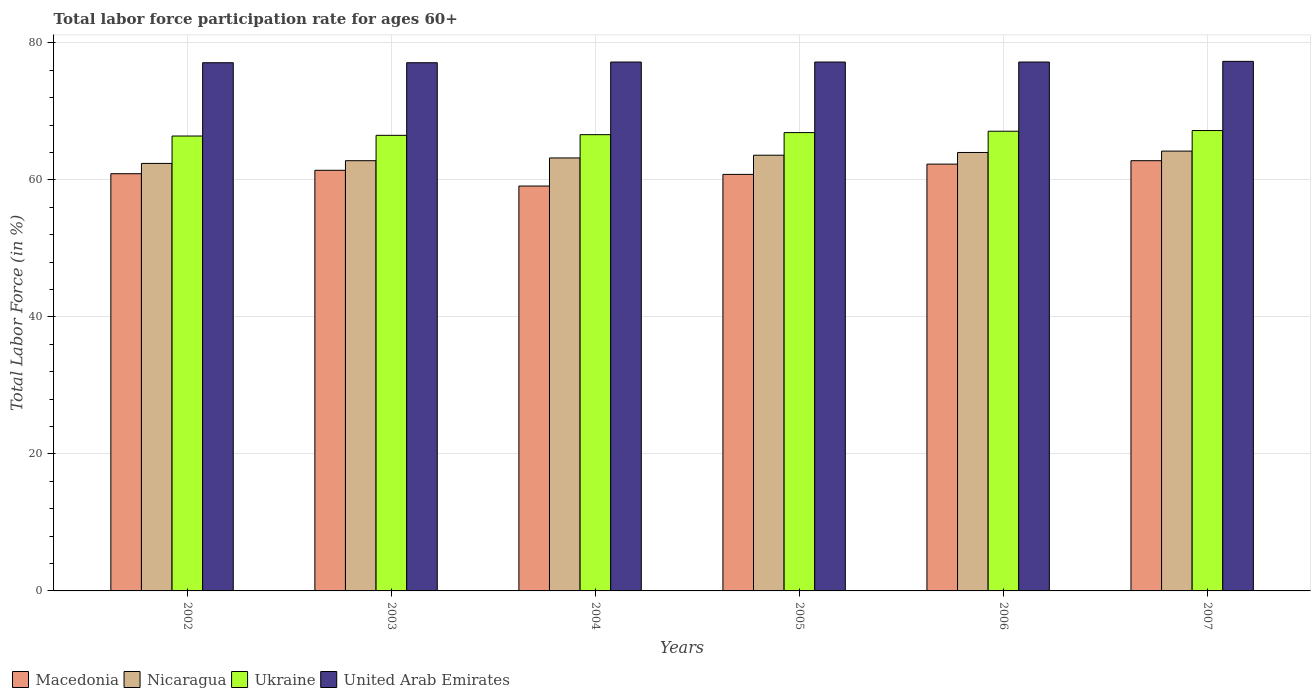How many different coloured bars are there?
Your answer should be very brief. 4. How many groups of bars are there?
Make the answer very short. 6. Are the number of bars per tick equal to the number of legend labels?
Your answer should be compact. Yes. Are the number of bars on each tick of the X-axis equal?
Your response must be concise. Yes. How many bars are there on the 1st tick from the right?
Give a very brief answer. 4. What is the labor force participation rate in United Arab Emirates in 2006?
Your answer should be very brief. 77.2. Across all years, what is the maximum labor force participation rate in Ukraine?
Your response must be concise. 67.2. Across all years, what is the minimum labor force participation rate in United Arab Emirates?
Give a very brief answer. 77.1. In which year was the labor force participation rate in Ukraine maximum?
Offer a very short reply. 2007. What is the total labor force participation rate in United Arab Emirates in the graph?
Your response must be concise. 463.1. What is the difference between the labor force participation rate in Ukraine in 2003 and that in 2005?
Make the answer very short. -0.4. What is the difference between the labor force participation rate in United Arab Emirates in 2007 and the labor force participation rate in Nicaragua in 2005?
Your response must be concise. 13.7. What is the average labor force participation rate in United Arab Emirates per year?
Provide a short and direct response. 77.18. In the year 2007, what is the difference between the labor force participation rate in Ukraine and labor force participation rate in Macedonia?
Your answer should be very brief. 4.4. What is the ratio of the labor force participation rate in Ukraine in 2002 to that in 2006?
Make the answer very short. 0.99. Is the difference between the labor force participation rate in Ukraine in 2006 and 2007 greater than the difference between the labor force participation rate in Macedonia in 2006 and 2007?
Your answer should be compact. Yes. What is the difference between the highest and the second highest labor force participation rate in Ukraine?
Your answer should be compact. 0.1. What is the difference between the highest and the lowest labor force participation rate in Nicaragua?
Offer a terse response. 1.8. Is it the case that in every year, the sum of the labor force participation rate in Nicaragua and labor force participation rate in United Arab Emirates is greater than the sum of labor force participation rate in Macedonia and labor force participation rate in Ukraine?
Offer a very short reply. Yes. What does the 4th bar from the left in 2002 represents?
Keep it short and to the point. United Arab Emirates. What does the 2nd bar from the right in 2006 represents?
Make the answer very short. Ukraine. How many bars are there?
Offer a very short reply. 24. Are all the bars in the graph horizontal?
Your answer should be compact. No. How many years are there in the graph?
Give a very brief answer. 6. Does the graph contain grids?
Your response must be concise. Yes. How are the legend labels stacked?
Your answer should be very brief. Horizontal. What is the title of the graph?
Provide a succinct answer. Total labor force participation rate for ages 60+. Does "North America" appear as one of the legend labels in the graph?
Provide a short and direct response. No. What is the label or title of the Y-axis?
Give a very brief answer. Total Labor Force (in %). What is the Total Labor Force (in %) of Macedonia in 2002?
Your response must be concise. 60.9. What is the Total Labor Force (in %) in Nicaragua in 2002?
Provide a short and direct response. 62.4. What is the Total Labor Force (in %) in Ukraine in 2002?
Give a very brief answer. 66.4. What is the Total Labor Force (in %) of United Arab Emirates in 2002?
Offer a terse response. 77.1. What is the Total Labor Force (in %) of Macedonia in 2003?
Give a very brief answer. 61.4. What is the Total Labor Force (in %) in Nicaragua in 2003?
Offer a very short reply. 62.8. What is the Total Labor Force (in %) in Ukraine in 2003?
Offer a very short reply. 66.5. What is the Total Labor Force (in %) in United Arab Emirates in 2003?
Your answer should be compact. 77.1. What is the Total Labor Force (in %) of Macedonia in 2004?
Give a very brief answer. 59.1. What is the Total Labor Force (in %) of Nicaragua in 2004?
Provide a succinct answer. 63.2. What is the Total Labor Force (in %) of Ukraine in 2004?
Provide a short and direct response. 66.6. What is the Total Labor Force (in %) in United Arab Emirates in 2004?
Provide a short and direct response. 77.2. What is the Total Labor Force (in %) in Macedonia in 2005?
Make the answer very short. 60.8. What is the Total Labor Force (in %) in Nicaragua in 2005?
Ensure brevity in your answer.  63.6. What is the Total Labor Force (in %) of Ukraine in 2005?
Make the answer very short. 66.9. What is the Total Labor Force (in %) in United Arab Emirates in 2005?
Ensure brevity in your answer.  77.2. What is the Total Labor Force (in %) in Macedonia in 2006?
Make the answer very short. 62.3. What is the Total Labor Force (in %) in Ukraine in 2006?
Your answer should be very brief. 67.1. What is the Total Labor Force (in %) in United Arab Emirates in 2006?
Offer a terse response. 77.2. What is the Total Labor Force (in %) of Macedonia in 2007?
Your answer should be very brief. 62.8. What is the Total Labor Force (in %) in Nicaragua in 2007?
Keep it short and to the point. 64.2. What is the Total Labor Force (in %) in Ukraine in 2007?
Provide a succinct answer. 67.2. What is the Total Labor Force (in %) of United Arab Emirates in 2007?
Make the answer very short. 77.3. Across all years, what is the maximum Total Labor Force (in %) of Macedonia?
Your answer should be compact. 62.8. Across all years, what is the maximum Total Labor Force (in %) of Nicaragua?
Provide a short and direct response. 64.2. Across all years, what is the maximum Total Labor Force (in %) in Ukraine?
Give a very brief answer. 67.2. Across all years, what is the maximum Total Labor Force (in %) in United Arab Emirates?
Your answer should be very brief. 77.3. Across all years, what is the minimum Total Labor Force (in %) in Macedonia?
Give a very brief answer. 59.1. Across all years, what is the minimum Total Labor Force (in %) in Nicaragua?
Offer a very short reply. 62.4. Across all years, what is the minimum Total Labor Force (in %) of Ukraine?
Your answer should be compact. 66.4. Across all years, what is the minimum Total Labor Force (in %) in United Arab Emirates?
Offer a very short reply. 77.1. What is the total Total Labor Force (in %) in Macedonia in the graph?
Offer a terse response. 367.3. What is the total Total Labor Force (in %) in Nicaragua in the graph?
Make the answer very short. 380.2. What is the total Total Labor Force (in %) of Ukraine in the graph?
Offer a very short reply. 400.7. What is the total Total Labor Force (in %) of United Arab Emirates in the graph?
Your answer should be compact. 463.1. What is the difference between the Total Labor Force (in %) of Macedonia in 2002 and that in 2003?
Provide a short and direct response. -0.5. What is the difference between the Total Labor Force (in %) in Nicaragua in 2002 and that in 2003?
Give a very brief answer. -0.4. What is the difference between the Total Labor Force (in %) of Ukraine in 2002 and that in 2003?
Keep it short and to the point. -0.1. What is the difference between the Total Labor Force (in %) in United Arab Emirates in 2002 and that in 2003?
Ensure brevity in your answer.  0. What is the difference between the Total Labor Force (in %) in Nicaragua in 2002 and that in 2004?
Keep it short and to the point. -0.8. What is the difference between the Total Labor Force (in %) in United Arab Emirates in 2002 and that in 2004?
Keep it short and to the point. -0.1. What is the difference between the Total Labor Force (in %) of Macedonia in 2002 and that in 2005?
Make the answer very short. 0.1. What is the difference between the Total Labor Force (in %) of Macedonia in 2002 and that in 2006?
Your answer should be compact. -1.4. What is the difference between the Total Labor Force (in %) of Nicaragua in 2002 and that in 2006?
Your answer should be very brief. -1.6. What is the difference between the Total Labor Force (in %) of Ukraine in 2002 and that in 2006?
Offer a very short reply. -0.7. What is the difference between the Total Labor Force (in %) in Macedonia in 2002 and that in 2007?
Ensure brevity in your answer.  -1.9. What is the difference between the Total Labor Force (in %) in Nicaragua in 2002 and that in 2007?
Provide a succinct answer. -1.8. What is the difference between the Total Labor Force (in %) of Nicaragua in 2003 and that in 2004?
Your answer should be compact. -0.4. What is the difference between the Total Labor Force (in %) of Nicaragua in 2003 and that in 2005?
Your answer should be very brief. -0.8. What is the difference between the Total Labor Force (in %) of Ukraine in 2003 and that in 2005?
Ensure brevity in your answer.  -0.4. What is the difference between the Total Labor Force (in %) in Macedonia in 2003 and that in 2006?
Give a very brief answer. -0.9. What is the difference between the Total Labor Force (in %) of Ukraine in 2003 and that in 2006?
Keep it short and to the point. -0.6. What is the difference between the Total Labor Force (in %) of Nicaragua in 2003 and that in 2007?
Offer a terse response. -1.4. What is the difference between the Total Labor Force (in %) of Ukraine in 2003 and that in 2007?
Provide a succinct answer. -0.7. What is the difference between the Total Labor Force (in %) in Macedonia in 2004 and that in 2005?
Offer a very short reply. -1.7. What is the difference between the Total Labor Force (in %) in Nicaragua in 2004 and that in 2005?
Make the answer very short. -0.4. What is the difference between the Total Labor Force (in %) in Ukraine in 2004 and that in 2005?
Give a very brief answer. -0.3. What is the difference between the Total Labor Force (in %) in Macedonia in 2004 and that in 2006?
Your answer should be compact. -3.2. What is the difference between the Total Labor Force (in %) in Ukraine in 2004 and that in 2006?
Your answer should be very brief. -0.5. What is the difference between the Total Labor Force (in %) of United Arab Emirates in 2004 and that in 2006?
Give a very brief answer. 0. What is the difference between the Total Labor Force (in %) of Macedonia in 2004 and that in 2007?
Offer a terse response. -3.7. What is the difference between the Total Labor Force (in %) of Nicaragua in 2004 and that in 2007?
Offer a terse response. -1. What is the difference between the Total Labor Force (in %) in Nicaragua in 2005 and that in 2006?
Offer a very short reply. -0.4. What is the difference between the Total Labor Force (in %) in Ukraine in 2005 and that in 2006?
Provide a short and direct response. -0.2. What is the difference between the Total Labor Force (in %) in United Arab Emirates in 2005 and that in 2007?
Make the answer very short. -0.1. What is the difference between the Total Labor Force (in %) of Macedonia in 2006 and that in 2007?
Offer a very short reply. -0.5. What is the difference between the Total Labor Force (in %) in Nicaragua in 2006 and that in 2007?
Your response must be concise. -0.2. What is the difference between the Total Labor Force (in %) of Ukraine in 2006 and that in 2007?
Offer a terse response. -0.1. What is the difference between the Total Labor Force (in %) of United Arab Emirates in 2006 and that in 2007?
Ensure brevity in your answer.  -0.1. What is the difference between the Total Labor Force (in %) of Macedonia in 2002 and the Total Labor Force (in %) of United Arab Emirates in 2003?
Make the answer very short. -16.2. What is the difference between the Total Labor Force (in %) in Nicaragua in 2002 and the Total Labor Force (in %) in Ukraine in 2003?
Offer a very short reply. -4.1. What is the difference between the Total Labor Force (in %) of Nicaragua in 2002 and the Total Labor Force (in %) of United Arab Emirates in 2003?
Provide a succinct answer. -14.7. What is the difference between the Total Labor Force (in %) in Ukraine in 2002 and the Total Labor Force (in %) in United Arab Emirates in 2003?
Make the answer very short. -10.7. What is the difference between the Total Labor Force (in %) of Macedonia in 2002 and the Total Labor Force (in %) of Ukraine in 2004?
Give a very brief answer. -5.7. What is the difference between the Total Labor Force (in %) in Macedonia in 2002 and the Total Labor Force (in %) in United Arab Emirates in 2004?
Make the answer very short. -16.3. What is the difference between the Total Labor Force (in %) of Nicaragua in 2002 and the Total Labor Force (in %) of United Arab Emirates in 2004?
Your answer should be compact. -14.8. What is the difference between the Total Labor Force (in %) of Macedonia in 2002 and the Total Labor Force (in %) of Nicaragua in 2005?
Keep it short and to the point. -2.7. What is the difference between the Total Labor Force (in %) of Macedonia in 2002 and the Total Labor Force (in %) of Ukraine in 2005?
Ensure brevity in your answer.  -6. What is the difference between the Total Labor Force (in %) in Macedonia in 2002 and the Total Labor Force (in %) in United Arab Emirates in 2005?
Give a very brief answer. -16.3. What is the difference between the Total Labor Force (in %) of Nicaragua in 2002 and the Total Labor Force (in %) of United Arab Emirates in 2005?
Keep it short and to the point. -14.8. What is the difference between the Total Labor Force (in %) of Macedonia in 2002 and the Total Labor Force (in %) of United Arab Emirates in 2006?
Provide a succinct answer. -16.3. What is the difference between the Total Labor Force (in %) of Nicaragua in 2002 and the Total Labor Force (in %) of Ukraine in 2006?
Provide a short and direct response. -4.7. What is the difference between the Total Labor Force (in %) in Nicaragua in 2002 and the Total Labor Force (in %) in United Arab Emirates in 2006?
Keep it short and to the point. -14.8. What is the difference between the Total Labor Force (in %) in Ukraine in 2002 and the Total Labor Force (in %) in United Arab Emirates in 2006?
Your answer should be compact. -10.8. What is the difference between the Total Labor Force (in %) of Macedonia in 2002 and the Total Labor Force (in %) of Nicaragua in 2007?
Offer a very short reply. -3.3. What is the difference between the Total Labor Force (in %) in Macedonia in 2002 and the Total Labor Force (in %) in United Arab Emirates in 2007?
Your answer should be very brief. -16.4. What is the difference between the Total Labor Force (in %) in Nicaragua in 2002 and the Total Labor Force (in %) in Ukraine in 2007?
Keep it short and to the point. -4.8. What is the difference between the Total Labor Force (in %) of Nicaragua in 2002 and the Total Labor Force (in %) of United Arab Emirates in 2007?
Offer a terse response. -14.9. What is the difference between the Total Labor Force (in %) of Macedonia in 2003 and the Total Labor Force (in %) of Nicaragua in 2004?
Give a very brief answer. -1.8. What is the difference between the Total Labor Force (in %) of Macedonia in 2003 and the Total Labor Force (in %) of United Arab Emirates in 2004?
Ensure brevity in your answer.  -15.8. What is the difference between the Total Labor Force (in %) of Nicaragua in 2003 and the Total Labor Force (in %) of United Arab Emirates in 2004?
Your answer should be very brief. -14.4. What is the difference between the Total Labor Force (in %) of Ukraine in 2003 and the Total Labor Force (in %) of United Arab Emirates in 2004?
Your response must be concise. -10.7. What is the difference between the Total Labor Force (in %) in Macedonia in 2003 and the Total Labor Force (in %) in Nicaragua in 2005?
Your answer should be very brief. -2.2. What is the difference between the Total Labor Force (in %) of Macedonia in 2003 and the Total Labor Force (in %) of United Arab Emirates in 2005?
Ensure brevity in your answer.  -15.8. What is the difference between the Total Labor Force (in %) of Nicaragua in 2003 and the Total Labor Force (in %) of United Arab Emirates in 2005?
Your response must be concise. -14.4. What is the difference between the Total Labor Force (in %) in Ukraine in 2003 and the Total Labor Force (in %) in United Arab Emirates in 2005?
Offer a very short reply. -10.7. What is the difference between the Total Labor Force (in %) of Macedonia in 2003 and the Total Labor Force (in %) of Ukraine in 2006?
Keep it short and to the point. -5.7. What is the difference between the Total Labor Force (in %) in Macedonia in 2003 and the Total Labor Force (in %) in United Arab Emirates in 2006?
Ensure brevity in your answer.  -15.8. What is the difference between the Total Labor Force (in %) of Nicaragua in 2003 and the Total Labor Force (in %) of Ukraine in 2006?
Provide a short and direct response. -4.3. What is the difference between the Total Labor Force (in %) in Nicaragua in 2003 and the Total Labor Force (in %) in United Arab Emirates in 2006?
Offer a terse response. -14.4. What is the difference between the Total Labor Force (in %) in Macedonia in 2003 and the Total Labor Force (in %) in United Arab Emirates in 2007?
Provide a succinct answer. -15.9. What is the difference between the Total Labor Force (in %) of Nicaragua in 2003 and the Total Labor Force (in %) of Ukraine in 2007?
Your answer should be very brief. -4.4. What is the difference between the Total Labor Force (in %) in Macedonia in 2004 and the Total Labor Force (in %) in Nicaragua in 2005?
Your answer should be compact. -4.5. What is the difference between the Total Labor Force (in %) of Macedonia in 2004 and the Total Labor Force (in %) of United Arab Emirates in 2005?
Offer a terse response. -18.1. What is the difference between the Total Labor Force (in %) in Nicaragua in 2004 and the Total Labor Force (in %) in United Arab Emirates in 2005?
Keep it short and to the point. -14. What is the difference between the Total Labor Force (in %) of Macedonia in 2004 and the Total Labor Force (in %) of Nicaragua in 2006?
Ensure brevity in your answer.  -4.9. What is the difference between the Total Labor Force (in %) in Macedonia in 2004 and the Total Labor Force (in %) in United Arab Emirates in 2006?
Your response must be concise. -18.1. What is the difference between the Total Labor Force (in %) in Nicaragua in 2004 and the Total Labor Force (in %) in United Arab Emirates in 2006?
Provide a succinct answer. -14. What is the difference between the Total Labor Force (in %) in Ukraine in 2004 and the Total Labor Force (in %) in United Arab Emirates in 2006?
Provide a succinct answer. -10.6. What is the difference between the Total Labor Force (in %) of Macedonia in 2004 and the Total Labor Force (in %) of Nicaragua in 2007?
Keep it short and to the point. -5.1. What is the difference between the Total Labor Force (in %) of Macedonia in 2004 and the Total Labor Force (in %) of United Arab Emirates in 2007?
Keep it short and to the point. -18.2. What is the difference between the Total Labor Force (in %) of Nicaragua in 2004 and the Total Labor Force (in %) of United Arab Emirates in 2007?
Ensure brevity in your answer.  -14.1. What is the difference between the Total Labor Force (in %) of Macedonia in 2005 and the Total Labor Force (in %) of Nicaragua in 2006?
Provide a short and direct response. -3.2. What is the difference between the Total Labor Force (in %) in Macedonia in 2005 and the Total Labor Force (in %) in United Arab Emirates in 2006?
Your answer should be compact. -16.4. What is the difference between the Total Labor Force (in %) of Ukraine in 2005 and the Total Labor Force (in %) of United Arab Emirates in 2006?
Offer a very short reply. -10.3. What is the difference between the Total Labor Force (in %) of Macedonia in 2005 and the Total Labor Force (in %) of United Arab Emirates in 2007?
Provide a short and direct response. -16.5. What is the difference between the Total Labor Force (in %) in Nicaragua in 2005 and the Total Labor Force (in %) in Ukraine in 2007?
Keep it short and to the point. -3.6. What is the difference between the Total Labor Force (in %) of Nicaragua in 2005 and the Total Labor Force (in %) of United Arab Emirates in 2007?
Offer a terse response. -13.7. What is the difference between the Total Labor Force (in %) in Macedonia in 2006 and the Total Labor Force (in %) in Nicaragua in 2007?
Your answer should be very brief. -1.9. What is the difference between the Total Labor Force (in %) in Nicaragua in 2006 and the Total Labor Force (in %) in United Arab Emirates in 2007?
Provide a short and direct response. -13.3. What is the average Total Labor Force (in %) of Macedonia per year?
Keep it short and to the point. 61.22. What is the average Total Labor Force (in %) of Nicaragua per year?
Offer a terse response. 63.37. What is the average Total Labor Force (in %) of Ukraine per year?
Keep it short and to the point. 66.78. What is the average Total Labor Force (in %) of United Arab Emirates per year?
Provide a succinct answer. 77.18. In the year 2002, what is the difference between the Total Labor Force (in %) of Macedonia and Total Labor Force (in %) of Nicaragua?
Provide a short and direct response. -1.5. In the year 2002, what is the difference between the Total Labor Force (in %) in Macedonia and Total Labor Force (in %) in United Arab Emirates?
Offer a very short reply. -16.2. In the year 2002, what is the difference between the Total Labor Force (in %) of Nicaragua and Total Labor Force (in %) of Ukraine?
Offer a very short reply. -4. In the year 2002, what is the difference between the Total Labor Force (in %) of Nicaragua and Total Labor Force (in %) of United Arab Emirates?
Your answer should be compact. -14.7. In the year 2003, what is the difference between the Total Labor Force (in %) in Macedonia and Total Labor Force (in %) in United Arab Emirates?
Keep it short and to the point. -15.7. In the year 2003, what is the difference between the Total Labor Force (in %) in Nicaragua and Total Labor Force (in %) in Ukraine?
Give a very brief answer. -3.7. In the year 2003, what is the difference between the Total Labor Force (in %) of Nicaragua and Total Labor Force (in %) of United Arab Emirates?
Provide a short and direct response. -14.3. In the year 2004, what is the difference between the Total Labor Force (in %) in Macedonia and Total Labor Force (in %) in Nicaragua?
Your answer should be compact. -4.1. In the year 2004, what is the difference between the Total Labor Force (in %) in Macedonia and Total Labor Force (in %) in United Arab Emirates?
Your answer should be compact. -18.1. In the year 2004, what is the difference between the Total Labor Force (in %) of Nicaragua and Total Labor Force (in %) of Ukraine?
Provide a short and direct response. -3.4. In the year 2004, what is the difference between the Total Labor Force (in %) of Ukraine and Total Labor Force (in %) of United Arab Emirates?
Make the answer very short. -10.6. In the year 2005, what is the difference between the Total Labor Force (in %) in Macedonia and Total Labor Force (in %) in Nicaragua?
Your answer should be compact. -2.8. In the year 2005, what is the difference between the Total Labor Force (in %) of Macedonia and Total Labor Force (in %) of United Arab Emirates?
Provide a succinct answer. -16.4. In the year 2005, what is the difference between the Total Labor Force (in %) in Ukraine and Total Labor Force (in %) in United Arab Emirates?
Offer a terse response. -10.3. In the year 2006, what is the difference between the Total Labor Force (in %) of Macedonia and Total Labor Force (in %) of Nicaragua?
Ensure brevity in your answer.  -1.7. In the year 2006, what is the difference between the Total Labor Force (in %) of Macedonia and Total Labor Force (in %) of Ukraine?
Offer a terse response. -4.8. In the year 2006, what is the difference between the Total Labor Force (in %) in Macedonia and Total Labor Force (in %) in United Arab Emirates?
Offer a terse response. -14.9. In the year 2006, what is the difference between the Total Labor Force (in %) of Nicaragua and Total Labor Force (in %) of United Arab Emirates?
Make the answer very short. -13.2. In the year 2007, what is the difference between the Total Labor Force (in %) of Macedonia and Total Labor Force (in %) of Nicaragua?
Your answer should be compact. -1.4. In the year 2007, what is the difference between the Total Labor Force (in %) of Macedonia and Total Labor Force (in %) of United Arab Emirates?
Offer a very short reply. -14.5. In the year 2007, what is the difference between the Total Labor Force (in %) of Nicaragua and Total Labor Force (in %) of Ukraine?
Your answer should be very brief. -3. In the year 2007, what is the difference between the Total Labor Force (in %) in Ukraine and Total Labor Force (in %) in United Arab Emirates?
Provide a short and direct response. -10.1. What is the ratio of the Total Labor Force (in %) of Macedonia in 2002 to that in 2003?
Offer a terse response. 0.99. What is the ratio of the Total Labor Force (in %) of Ukraine in 2002 to that in 2003?
Your answer should be very brief. 1. What is the ratio of the Total Labor Force (in %) of Macedonia in 2002 to that in 2004?
Provide a short and direct response. 1.03. What is the ratio of the Total Labor Force (in %) in Nicaragua in 2002 to that in 2004?
Your answer should be very brief. 0.99. What is the ratio of the Total Labor Force (in %) of Ukraine in 2002 to that in 2004?
Give a very brief answer. 1. What is the ratio of the Total Labor Force (in %) of Macedonia in 2002 to that in 2005?
Give a very brief answer. 1. What is the ratio of the Total Labor Force (in %) of Nicaragua in 2002 to that in 2005?
Provide a succinct answer. 0.98. What is the ratio of the Total Labor Force (in %) of United Arab Emirates in 2002 to that in 2005?
Your response must be concise. 1. What is the ratio of the Total Labor Force (in %) in Macedonia in 2002 to that in 2006?
Give a very brief answer. 0.98. What is the ratio of the Total Labor Force (in %) of Ukraine in 2002 to that in 2006?
Provide a short and direct response. 0.99. What is the ratio of the Total Labor Force (in %) of Macedonia in 2002 to that in 2007?
Make the answer very short. 0.97. What is the ratio of the Total Labor Force (in %) in Nicaragua in 2002 to that in 2007?
Your answer should be very brief. 0.97. What is the ratio of the Total Labor Force (in %) of Ukraine in 2002 to that in 2007?
Give a very brief answer. 0.99. What is the ratio of the Total Labor Force (in %) in Macedonia in 2003 to that in 2004?
Provide a succinct answer. 1.04. What is the ratio of the Total Labor Force (in %) in Nicaragua in 2003 to that in 2004?
Your answer should be very brief. 0.99. What is the ratio of the Total Labor Force (in %) of Macedonia in 2003 to that in 2005?
Offer a very short reply. 1.01. What is the ratio of the Total Labor Force (in %) in Nicaragua in 2003 to that in 2005?
Your answer should be very brief. 0.99. What is the ratio of the Total Labor Force (in %) in Ukraine in 2003 to that in 2005?
Your response must be concise. 0.99. What is the ratio of the Total Labor Force (in %) of United Arab Emirates in 2003 to that in 2005?
Keep it short and to the point. 1. What is the ratio of the Total Labor Force (in %) of Macedonia in 2003 to that in 2006?
Provide a succinct answer. 0.99. What is the ratio of the Total Labor Force (in %) of Nicaragua in 2003 to that in 2006?
Your answer should be very brief. 0.98. What is the ratio of the Total Labor Force (in %) of Macedonia in 2003 to that in 2007?
Offer a terse response. 0.98. What is the ratio of the Total Labor Force (in %) of Nicaragua in 2003 to that in 2007?
Make the answer very short. 0.98. What is the ratio of the Total Labor Force (in %) of Ukraine in 2003 to that in 2007?
Keep it short and to the point. 0.99. What is the ratio of the Total Labor Force (in %) in Macedonia in 2004 to that in 2005?
Provide a short and direct response. 0.97. What is the ratio of the Total Labor Force (in %) of Ukraine in 2004 to that in 2005?
Give a very brief answer. 1. What is the ratio of the Total Labor Force (in %) of United Arab Emirates in 2004 to that in 2005?
Provide a short and direct response. 1. What is the ratio of the Total Labor Force (in %) in Macedonia in 2004 to that in 2006?
Offer a terse response. 0.95. What is the ratio of the Total Labor Force (in %) of Nicaragua in 2004 to that in 2006?
Offer a terse response. 0.99. What is the ratio of the Total Labor Force (in %) in Macedonia in 2004 to that in 2007?
Provide a short and direct response. 0.94. What is the ratio of the Total Labor Force (in %) of Nicaragua in 2004 to that in 2007?
Offer a terse response. 0.98. What is the ratio of the Total Labor Force (in %) of Ukraine in 2004 to that in 2007?
Keep it short and to the point. 0.99. What is the ratio of the Total Labor Force (in %) in Macedonia in 2005 to that in 2006?
Ensure brevity in your answer.  0.98. What is the ratio of the Total Labor Force (in %) in Nicaragua in 2005 to that in 2006?
Ensure brevity in your answer.  0.99. What is the ratio of the Total Labor Force (in %) in Ukraine in 2005 to that in 2006?
Ensure brevity in your answer.  1. What is the ratio of the Total Labor Force (in %) in Macedonia in 2005 to that in 2007?
Offer a very short reply. 0.97. What is the ratio of the Total Labor Force (in %) in Ukraine in 2005 to that in 2007?
Your answer should be very brief. 1. What is the ratio of the Total Labor Force (in %) in Macedonia in 2006 to that in 2007?
Offer a terse response. 0.99. What is the ratio of the Total Labor Force (in %) of Ukraine in 2006 to that in 2007?
Offer a very short reply. 1. What is the ratio of the Total Labor Force (in %) in United Arab Emirates in 2006 to that in 2007?
Your answer should be compact. 1. What is the difference between the highest and the second highest Total Labor Force (in %) of Nicaragua?
Give a very brief answer. 0.2. What is the difference between the highest and the second highest Total Labor Force (in %) in Ukraine?
Your response must be concise. 0.1. What is the difference between the highest and the second highest Total Labor Force (in %) in United Arab Emirates?
Ensure brevity in your answer.  0.1. What is the difference between the highest and the lowest Total Labor Force (in %) in Macedonia?
Ensure brevity in your answer.  3.7. What is the difference between the highest and the lowest Total Labor Force (in %) in Nicaragua?
Give a very brief answer. 1.8. What is the difference between the highest and the lowest Total Labor Force (in %) of United Arab Emirates?
Provide a succinct answer. 0.2. 